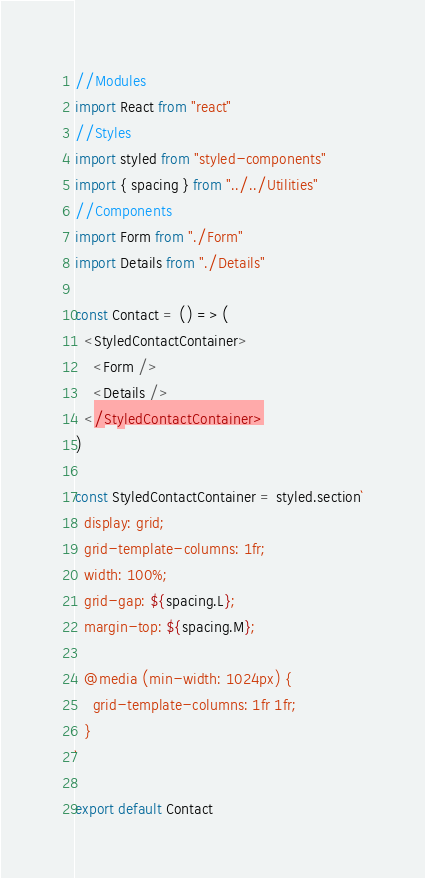Convert code to text. <code><loc_0><loc_0><loc_500><loc_500><_JavaScript_>//Modules
import React from "react"
//Styles
import styled from "styled-components"
import { spacing } from "../../Utilities"
//Components
import Form from "./Form"
import Details from "./Details"

const Contact = () => (
  <StyledContactContainer>
    <Form />
    <Details />
  </StyledContactContainer>
)

const StyledContactContainer = styled.section`
  display: grid;
  grid-template-columns: 1fr;
  width: 100%;
  grid-gap: ${spacing.L};
  margin-top: ${spacing.M};

  @media (min-width: 1024px) {
    grid-template-columns: 1fr 1fr;
  }
`

export default Contact
</code> 